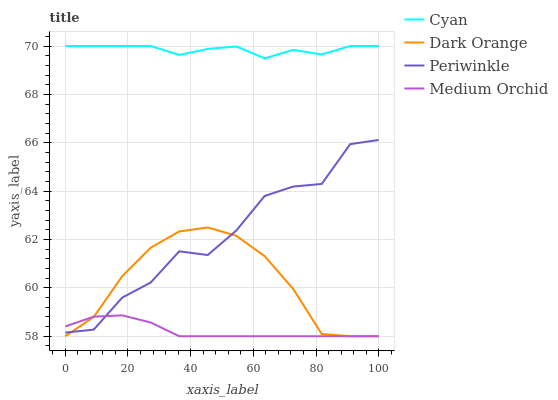Does Medium Orchid have the minimum area under the curve?
Answer yes or no. Yes. Does Cyan have the maximum area under the curve?
Answer yes or no. Yes. Does Periwinkle have the minimum area under the curve?
Answer yes or no. No. Does Periwinkle have the maximum area under the curve?
Answer yes or no. No. Is Medium Orchid the smoothest?
Answer yes or no. Yes. Is Periwinkle the roughest?
Answer yes or no. Yes. Is Periwinkle the smoothest?
Answer yes or no. No. Is Medium Orchid the roughest?
Answer yes or no. No. Does Medium Orchid have the lowest value?
Answer yes or no. Yes. Does Periwinkle have the lowest value?
Answer yes or no. No. Does Cyan have the highest value?
Answer yes or no. Yes. Does Periwinkle have the highest value?
Answer yes or no. No. Is Periwinkle less than Cyan?
Answer yes or no. Yes. Is Cyan greater than Dark Orange?
Answer yes or no. Yes. Does Medium Orchid intersect Dark Orange?
Answer yes or no. Yes. Is Medium Orchid less than Dark Orange?
Answer yes or no. No. Is Medium Orchid greater than Dark Orange?
Answer yes or no. No. Does Periwinkle intersect Cyan?
Answer yes or no. No. 